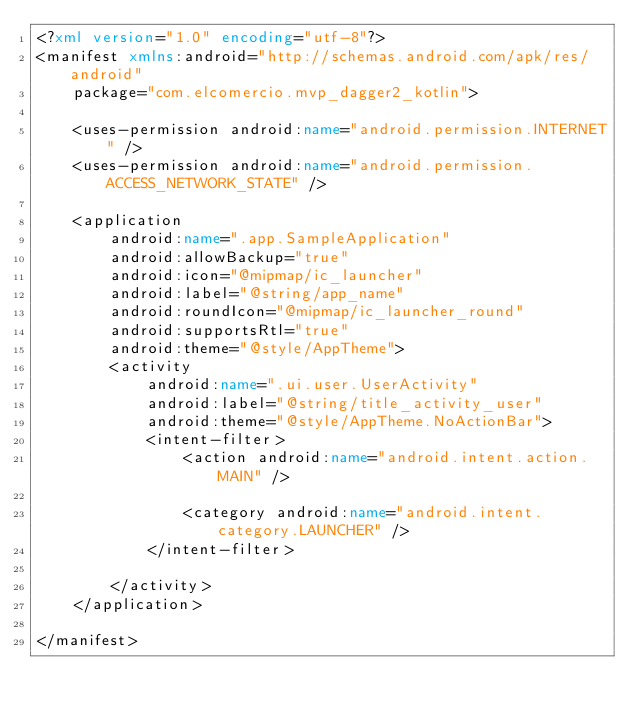Convert code to text. <code><loc_0><loc_0><loc_500><loc_500><_XML_><?xml version="1.0" encoding="utf-8"?>
<manifest xmlns:android="http://schemas.android.com/apk/res/android"
    package="com.elcomercio.mvp_dagger2_kotlin">

    <uses-permission android:name="android.permission.INTERNET" />
    <uses-permission android:name="android.permission.ACCESS_NETWORK_STATE" />

    <application
        android:name=".app.SampleApplication"
        android:allowBackup="true"
        android:icon="@mipmap/ic_launcher"
        android:label="@string/app_name"
        android:roundIcon="@mipmap/ic_launcher_round"
        android:supportsRtl="true"
        android:theme="@style/AppTheme">
        <activity
            android:name=".ui.user.UserActivity"
            android:label="@string/title_activity_user"
            android:theme="@style/AppTheme.NoActionBar">
            <intent-filter>
                <action android:name="android.intent.action.MAIN" />

                <category android:name="android.intent.category.LAUNCHER" />
            </intent-filter>

        </activity>
    </application>

</manifest></code> 